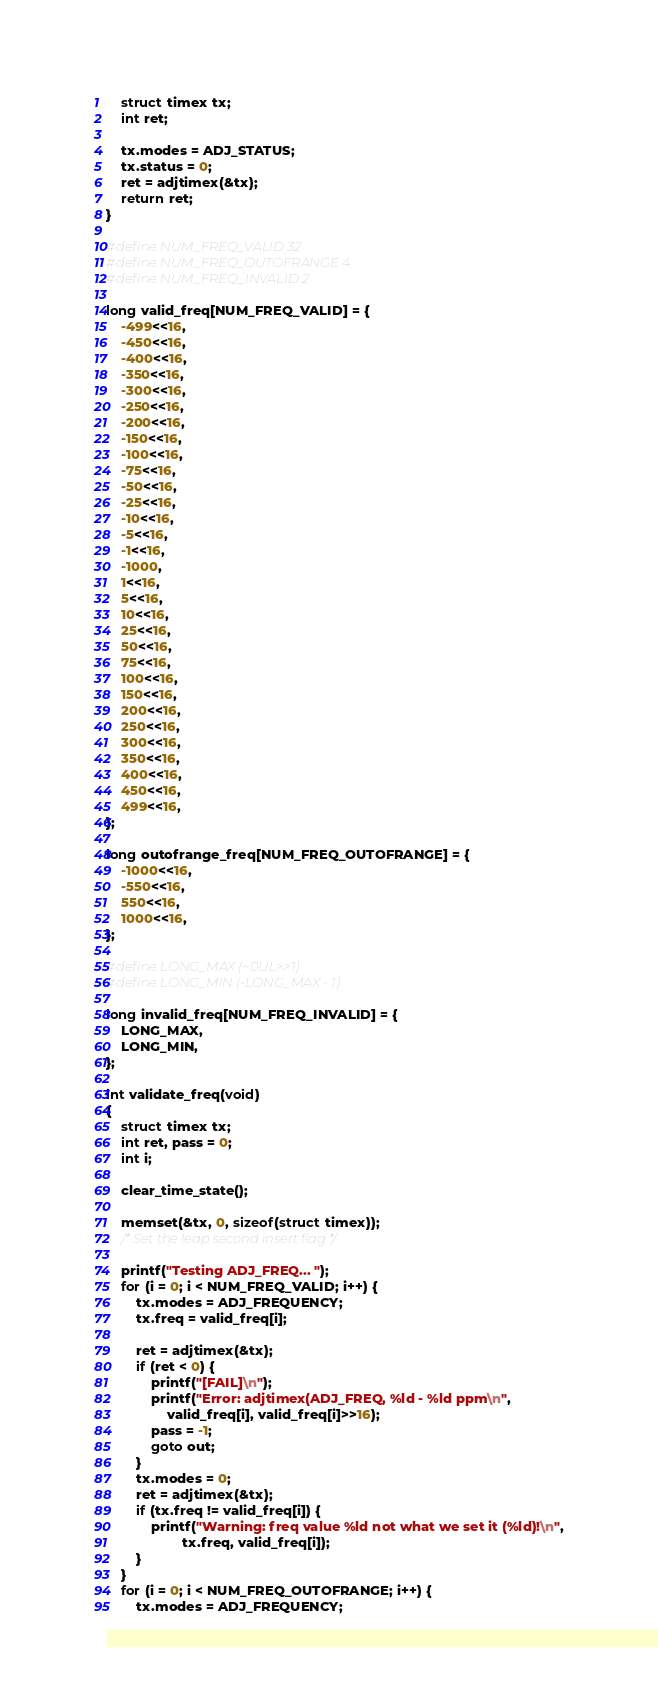Convert code to text. <code><loc_0><loc_0><loc_500><loc_500><_C_>	struct timex tx;
	int ret;

	tx.modes = ADJ_STATUS;
	tx.status = 0;
	ret = adjtimex(&tx);
	return ret;
}

#define NUM_FREQ_VALID 32
#define NUM_FREQ_OUTOFRANGE 4
#define NUM_FREQ_INVALID 2

long valid_freq[NUM_FREQ_VALID] = {
	-499<<16,
	-450<<16,
	-400<<16,
	-350<<16,
	-300<<16,
	-250<<16,
	-200<<16,
	-150<<16,
	-100<<16,
	-75<<16,
	-50<<16,
	-25<<16,
	-10<<16,
	-5<<16,
	-1<<16,
	-1000,
	1<<16,
	5<<16,
	10<<16,
	25<<16,
	50<<16,
	75<<16,
	100<<16,
	150<<16,
	200<<16,
	250<<16,
	300<<16,
	350<<16,
	400<<16,
	450<<16,
	499<<16,
};

long outofrange_freq[NUM_FREQ_OUTOFRANGE] = {
	-1000<<16,
	-550<<16,
	550<<16,
	1000<<16,
};

#define LONG_MAX (~0UL>>1)
#define LONG_MIN (-LONG_MAX - 1)

long invalid_freq[NUM_FREQ_INVALID] = {
	LONG_MAX,
	LONG_MIN,
};

int validate_freq(void)
{
	struct timex tx;
	int ret, pass = 0;
	int i;

	clear_time_state();

	memset(&tx, 0, sizeof(struct timex));
	/* Set the leap second insert flag */

	printf("Testing ADJ_FREQ... ");
	for (i = 0; i < NUM_FREQ_VALID; i++) {
		tx.modes = ADJ_FREQUENCY;
		tx.freq = valid_freq[i];

		ret = adjtimex(&tx);
		if (ret < 0) {
			printf("[FAIL]\n");
			printf("Error: adjtimex(ADJ_FREQ, %ld - %ld ppm\n",
				valid_freq[i], valid_freq[i]>>16);
			pass = -1;
			goto out;
		}
		tx.modes = 0;
		ret = adjtimex(&tx);
		if (tx.freq != valid_freq[i]) {
			printf("Warning: freq value %ld not what we set it (%ld)!\n",
					tx.freq, valid_freq[i]);
		}
	}
	for (i = 0; i < NUM_FREQ_OUTOFRANGE; i++) {
		tx.modes = ADJ_FREQUENCY;</code> 